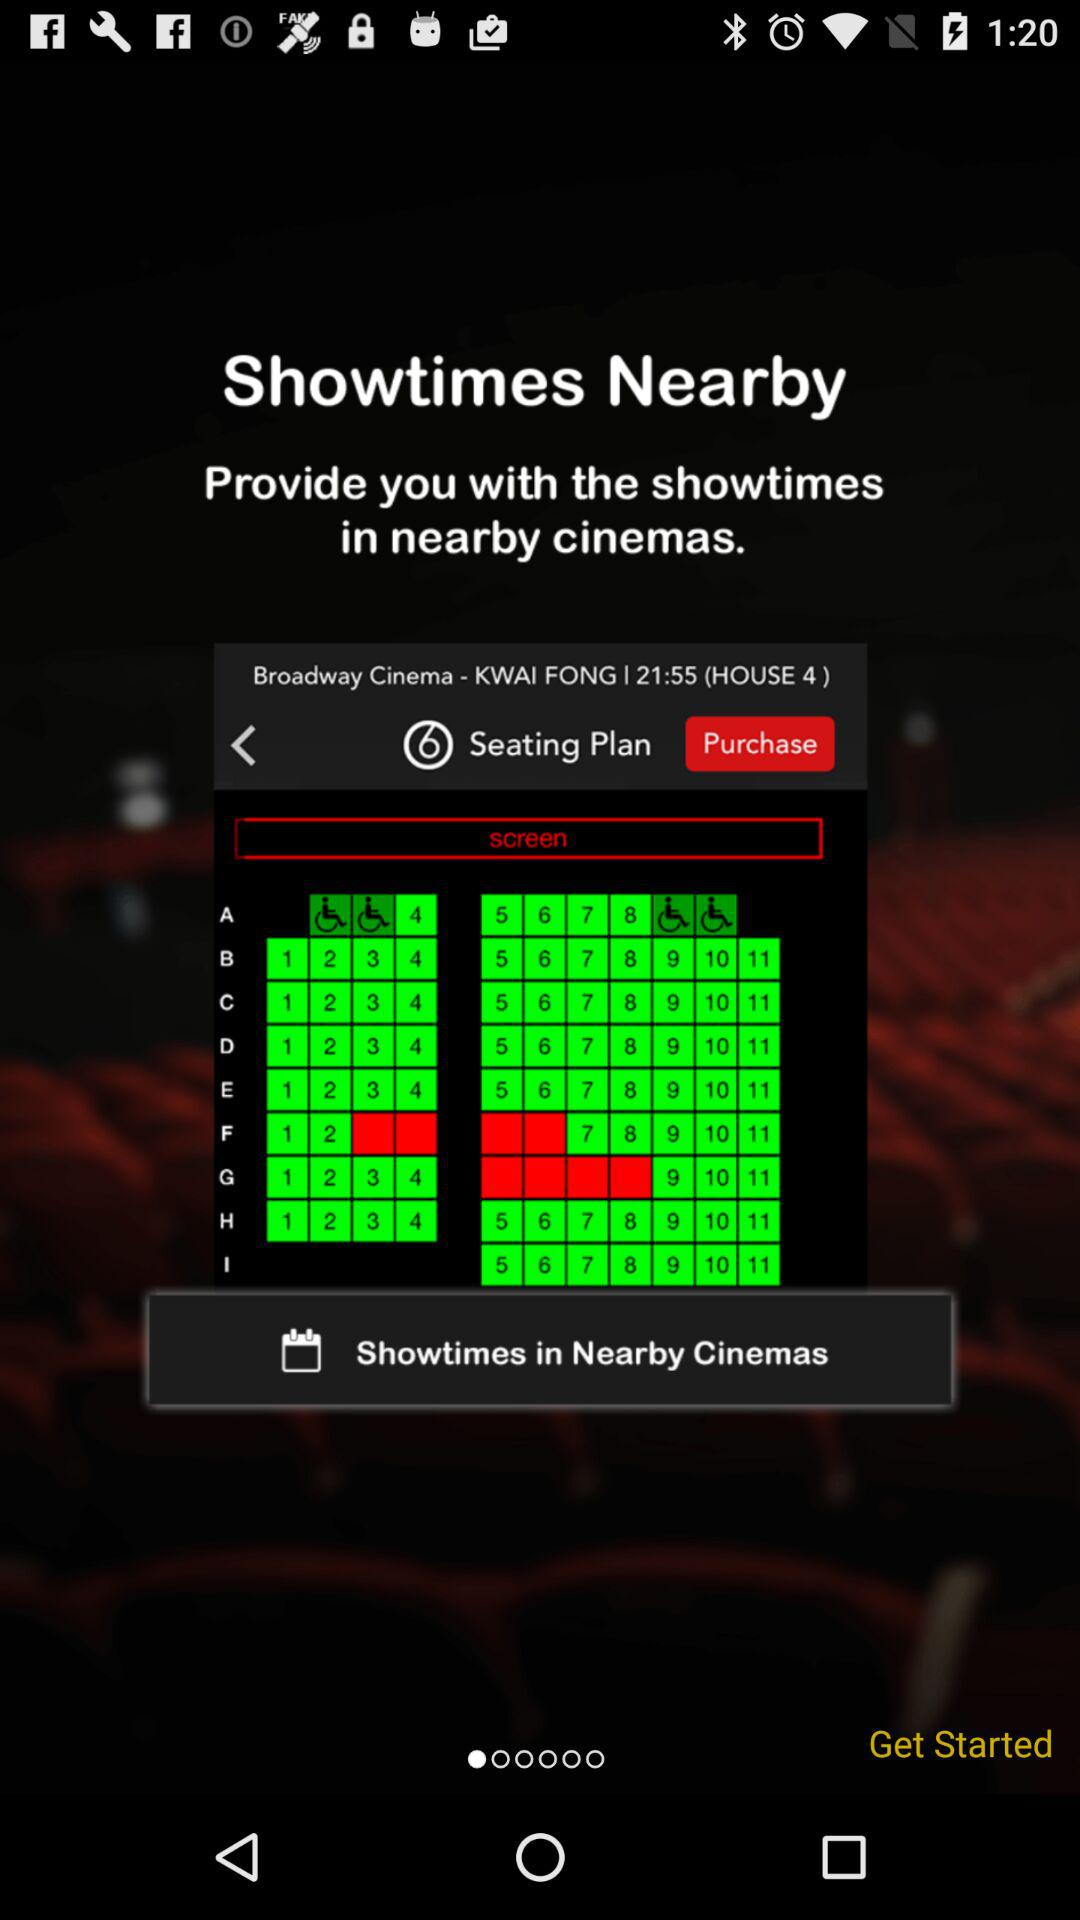What is the house number? The house number is 4. 